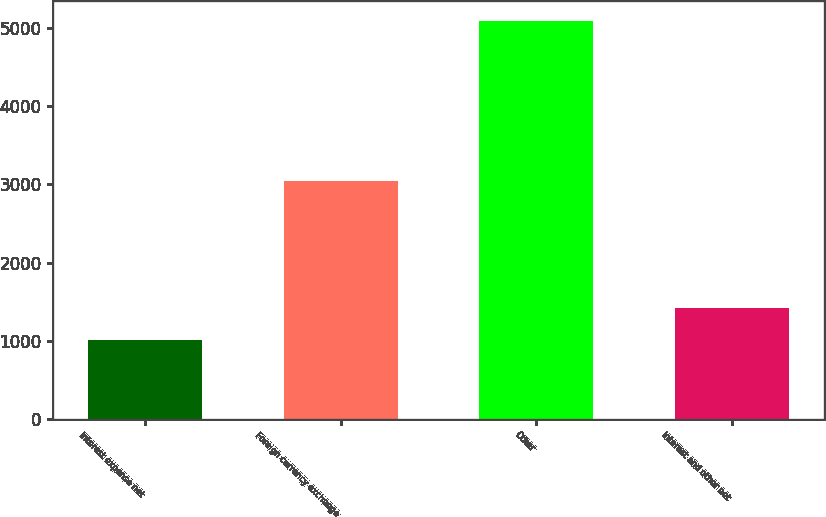Convert chart to OTSL. <chart><loc_0><loc_0><loc_500><loc_500><bar_chart><fcel>Interest expense net<fcel>Foreign currency exchange<fcel>Other<fcel>Interest and other net<nl><fcel>1005<fcel>3038<fcel>5091<fcel>1413.6<nl></chart> 